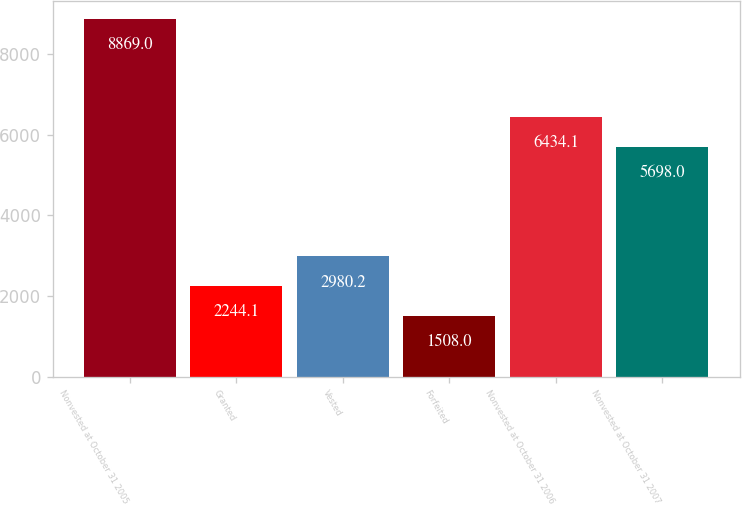Convert chart to OTSL. <chart><loc_0><loc_0><loc_500><loc_500><bar_chart><fcel>Nonvested at October 31 2005<fcel>Granted<fcel>Vested<fcel>Forfeited<fcel>Nonvested at October 31 2006<fcel>Nonvested at October 31 2007<nl><fcel>8869<fcel>2244.1<fcel>2980.2<fcel>1508<fcel>6434.1<fcel>5698<nl></chart> 